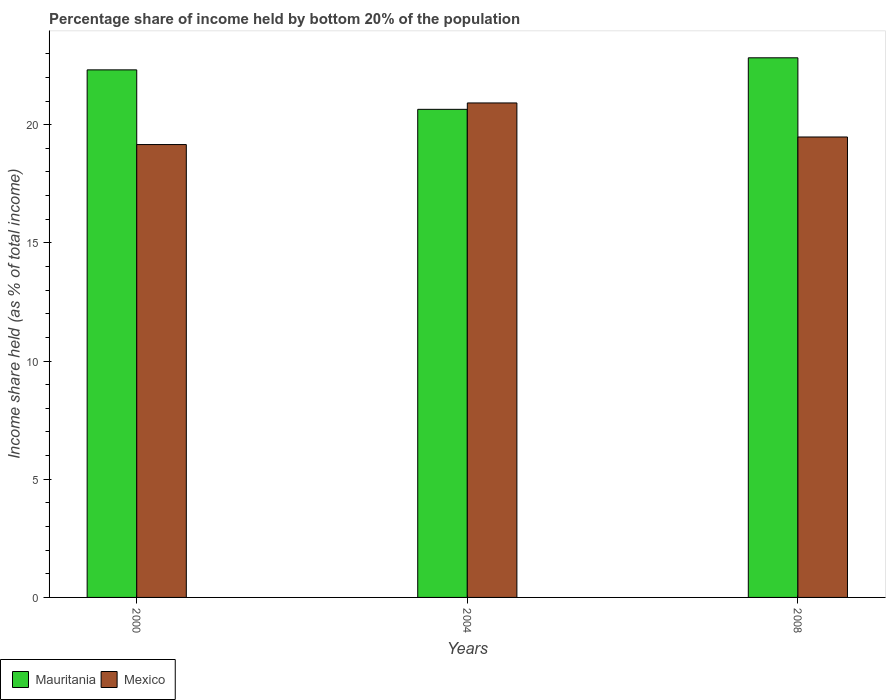How many groups of bars are there?
Offer a terse response. 3. Are the number of bars per tick equal to the number of legend labels?
Give a very brief answer. Yes. How many bars are there on the 3rd tick from the left?
Provide a succinct answer. 2. What is the label of the 3rd group of bars from the left?
Keep it short and to the point. 2008. In how many cases, is the number of bars for a given year not equal to the number of legend labels?
Your answer should be compact. 0. What is the share of income held by bottom 20% of the population in Mexico in 2004?
Make the answer very short. 20.92. Across all years, what is the maximum share of income held by bottom 20% of the population in Mexico?
Offer a terse response. 20.92. Across all years, what is the minimum share of income held by bottom 20% of the population in Mexico?
Provide a short and direct response. 19.16. In which year was the share of income held by bottom 20% of the population in Mexico maximum?
Provide a short and direct response. 2004. In which year was the share of income held by bottom 20% of the population in Mauritania minimum?
Keep it short and to the point. 2004. What is the total share of income held by bottom 20% of the population in Mauritania in the graph?
Your answer should be compact. 65.8. What is the difference between the share of income held by bottom 20% of the population in Mauritania in 2000 and that in 2008?
Give a very brief answer. -0.51. What is the difference between the share of income held by bottom 20% of the population in Mexico in 2000 and the share of income held by bottom 20% of the population in Mauritania in 2004?
Keep it short and to the point. -1.49. What is the average share of income held by bottom 20% of the population in Mexico per year?
Offer a very short reply. 19.85. In the year 2008, what is the difference between the share of income held by bottom 20% of the population in Mauritania and share of income held by bottom 20% of the population in Mexico?
Your answer should be compact. 3.35. In how many years, is the share of income held by bottom 20% of the population in Mexico greater than 15 %?
Offer a terse response. 3. What is the ratio of the share of income held by bottom 20% of the population in Mexico in 2004 to that in 2008?
Offer a terse response. 1.07. Is the share of income held by bottom 20% of the population in Mauritania in 2000 less than that in 2004?
Your answer should be compact. No. Is the difference between the share of income held by bottom 20% of the population in Mauritania in 2004 and 2008 greater than the difference between the share of income held by bottom 20% of the population in Mexico in 2004 and 2008?
Offer a terse response. No. What is the difference between the highest and the second highest share of income held by bottom 20% of the population in Mauritania?
Offer a terse response. 0.51. What is the difference between the highest and the lowest share of income held by bottom 20% of the population in Mexico?
Make the answer very short. 1.76. In how many years, is the share of income held by bottom 20% of the population in Mexico greater than the average share of income held by bottom 20% of the population in Mexico taken over all years?
Provide a succinct answer. 1. Is the sum of the share of income held by bottom 20% of the population in Mauritania in 2000 and 2004 greater than the maximum share of income held by bottom 20% of the population in Mexico across all years?
Give a very brief answer. Yes. What does the 1st bar from the left in 2004 represents?
Provide a succinct answer. Mauritania. What does the 2nd bar from the right in 2004 represents?
Provide a succinct answer. Mauritania. How many years are there in the graph?
Your answer should be very brief. 3. Does the graph contain any zero values?
Offer a terse response. No. Does the graph contain grids?
Provide a succinct answer. No. What is the title of the graph?
Provide a short and direct response. Percentage share of income held by bottom 20% of the population. Does "Congo (Democratic)" appear as one of the legend labels in the graph?
Your answer should be compact. No. What is the label or title of the Y-axis?
Your response must be concise. Income share held (as % of total income). What is the Income share held (as % of total income) of Mauritania in 2000?
Offer a terse response. 22.32. What is the Income share held (as % of total income) of Mexico in 2000?
Make the answer very short. 19.16. What is the Income share held (as % of total income) of Mauritania in 2004?
Keep it short and to the point. 20.65. What is the Income share held (as % of total income) in Mexico in 2004?
Offer a very short reply. 20.92. What is the Income share held (as % of total income) in Mauritania in 2008?
Offer a terse response. 22.83. What is the Income share held (as % of total income) of Mexico in 2008?
Provide a short and direct response. 19.48. Across all years, what is the maximum Income share held (as % of total income) of Mauritania?
Your response must be concise. 22.83. Across all years, what is the maximum Income share held (as % of total income) in Mexico?
Provide a succinct answer. 20.92. Across all years, what is the minimum Income share held (as % of total income) in Mauritania?
Give a very brief answer. 20.65. Across all years, what is the minimum Income share held (as % of total income) of Mexico?
Provide a succinct answer. 19.16. What is the total Income share held (as % of total income) of Mauritania in the graph?
Offer a very short reply. 65.8. What is the total Income share held (as % of total income) of Mexico in the graph?
Offer a terse response. 59.56. What is the difference between the Income share held (as % of total income) in Mauritania in 2000 and that in 2004?
Your response must be concise. 1.67. What is the difference between the Income share held (as % of total income) of Mexico in 2000 and that in 2004?
Your answer should be compact. -1.76. What is the difference between the Income share held (as % of total income) in Mauritania in 2000 and that in 2008?
Make the answer very short. -0.51. What is the difference between the Income share held (as % of total income) of Mexico in 2000 and that in 2008?
Your answer should be very brief. -0.32. What is the difference between the Income share held (as % of total income) in Mauritania in 2004 and that in 2008?
Keep it short and to the point. -2.18. What is the difference between the Income share held (as % of total income) of Mexico in 2004 and that in 2008?
Provide a short and direct response. 1.44. What is the difference between the Income share held (as % of total income) in Mauritania in 2000 and the Income share held (as % of total income) in Mexico in 2008?
Provide a short and direct response. 2.84. What is the difference between the Income share held (as % of total income) of Mauritania in 2004 and the Income share held (as % of total income) of Mexico in 2008?
Provide a succinct answer. 1.17. What is the average Income share held (as % of total income) in Mauritania per year?
Offer a very short reply. 21.93. What is the average Income share held (as % of total income) of Mexico per year?
Keep it short and to the point. 19.85. In the year 2000, what is the difference between the Income share held (as % of total income) of Mauritania and Income share held (as % of total income) of Mexico?
Offer a very short reply. 3.16. In the year 2004, what is the difference between the Income share held (as % of total income) in Mauritania and Income share held (as % of total income) in Mexico?
Your answer should be very brief. -0.27. In the year 2008, what is the difference between the Income share held (as % of total income) in Mauritania and Income share held (as % of total income) in Mexico?
Give a very brief answer. 3.35. What is the ratio of the Income share held (as % of total income) in Mauritania in 2000 to that in 2004?
Provide a short and direct response. 1.08. What is the ratio of the Income share held (as % of total income) in Mexico in 2000 to that in 2004?
Provide a succinct answer. 0.92. What is the ratio of the Income share held (as % of total income) in Mauritania in 2000 to that in 2008?
Ensure brevity in your answer.  0.98. What is the ratio of the Income share held (as % of total income) of Mexico in 2000 to that in 2008?
Provide a short and direct response. 0.98. What is the ratio of the Income share held (as % of total income) in Mauritania in 2004 to that in 2008?
Your answer should be very brief. 0.9. What is the ratio of the Income share held (as % of total income) of Mexico in 2004 to that in 2008?
Your answer should be compact. 1.07. What is the difference between the highest and the second highest Income share held (as % of total income) in Mauritania?
Your response must be concise. 0.51. What is the difference between the highest and the second highest Income share held (as % of total income) in Mexico?
Ensure brevity in your answer.  1.44. What is the difference between the highest and the lowest Income share held (as % of total income) of Mauritania?
Your answer should be compact. 2.18. What is the difference between the highest and the lowest Income share held (as % of total income) of Mexico?
Give a very brief answer. 1.76. 